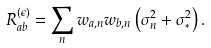<formula> <loc_0><loc_0><loc_500><loc_500>R ^ { ( \epsilon ) } _ { a b } = \sum _ { n } w _ { a , n } w _ { b , n } \left ( \sigma _ { n } ^ { 2 } + \sigma _ { * } ^ { 2 } \right ) .</formula> 